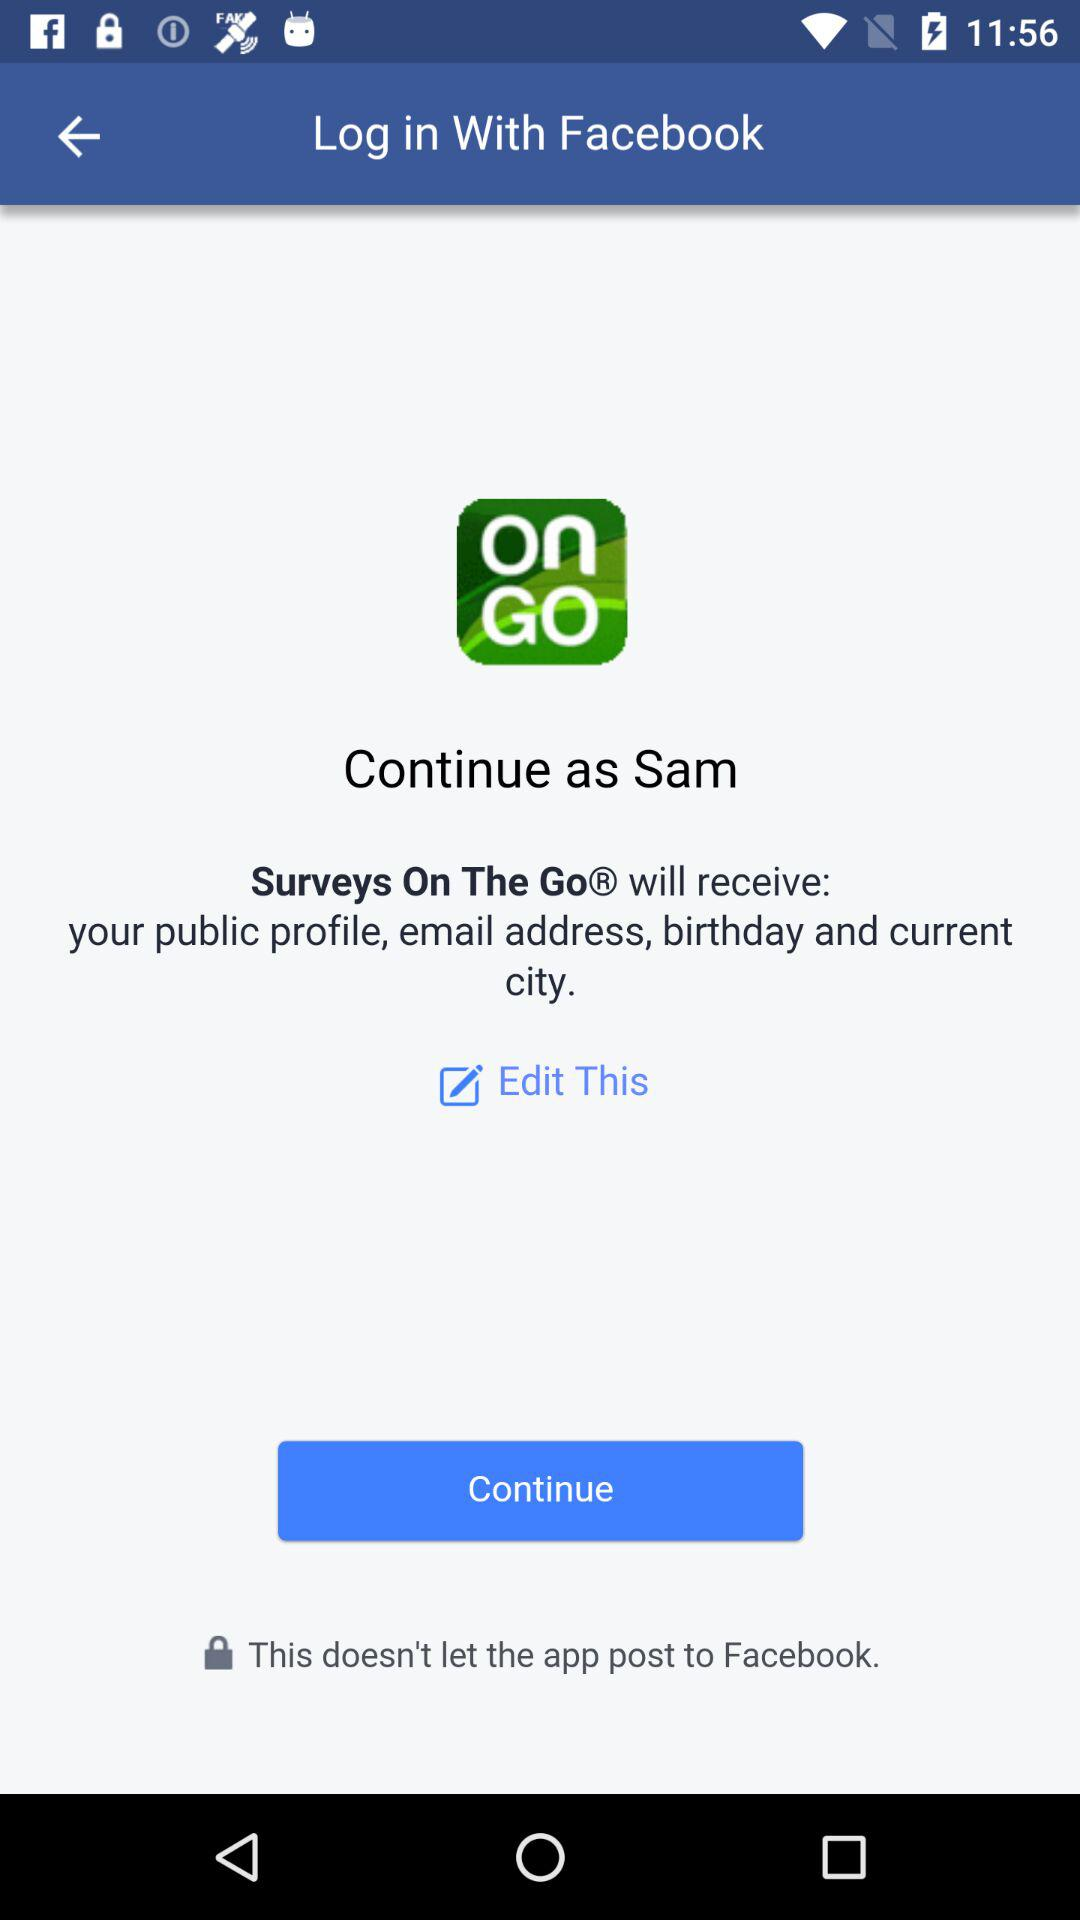What is the name of the user? The name of the user is Sam. 